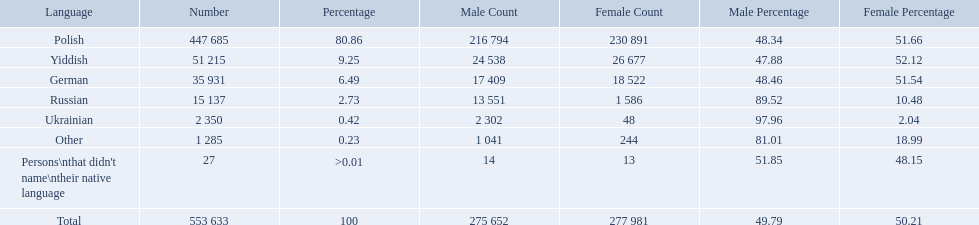What was the least spoken language Ukrainian. What was the most spoken? Polish. What languages are there? Polish, Yiddish, German, Russian, Ukrainian. What numbers speak these languages? 447 685, 51 215, 35 931, 15 137, 2 350. What numbers are not listed as speaking these languages? 1 285, 27. What are the totals of these speakers? 553 633. What were the languages in plock governorate? Polish, Yiddish, German, Russian, Ukrainian, Other. Which language has a value of .42? Ukrainian. 